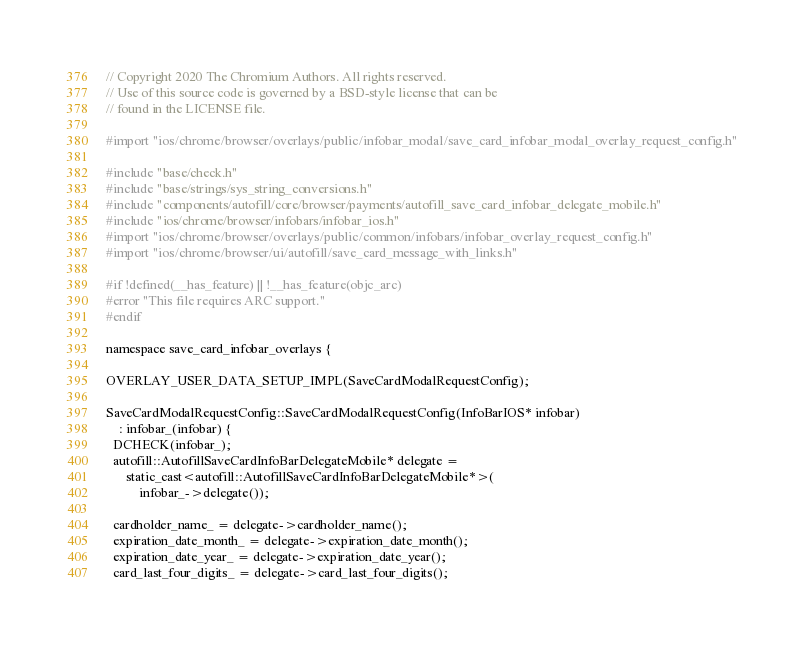<code> <loc_0><loc_0><loc_500><loc_500><_ObjectiveC_>// Copyright 2020 The Chromium Authors. All rights reserved.
// Use of this source code is governed by a BSD-style license that can be
// found in the LICENSE file.

#import "ios/chrome/browser/overlays/public/infobar_modal/save_card_infobar_modal_overlay_request_config.h"

#include "base/check.h"
#include "base/strings/sys_string_conversions.h"
#include "components/autofill/core/browser/payments/autofill_save_card_infobar_delegate_mobile.h"
#include "ios/chrome/browser/infobars/infobar_ios.h"
#import "ios/chrome/browser/overlays/public/common/infobars/infobar_overlay_request_config.h"
#import "ios/chrome/browser/ui/autofill/save_card_message_with_links.h"

#if !defined(__has_feature) || !__has_feature(objc_arc)
#error "This file requires ARC support."
#endif

namespace save_card_infobar_overlays {

OVERLAY_USER_DATA_SETUP_IMPL(SaveCardModalRequestConfig);

SaveCardModalRequestConfig::SaveCardModalRequestConfig(InfoBarIOS* infobar)
    : infobar_(infobar) {
  DCHECK(infobar_);
  autofill::AutofillSaveCardInfoBarDelegateMobile* delegate =
      static_cast<autofill::AutofillSaveCardInfoBarDelegateMobile*>(
          infobar_->delegate());

  cardholder_name_ = delegate->cardholder_name();
  expiration_date_month_ = delegate->expiration_date_month();
  expiration_date_year_ = delegate->expiration_date_year();
  card_last_four_digits_ = delegate->card_last_four_digits();</code> 